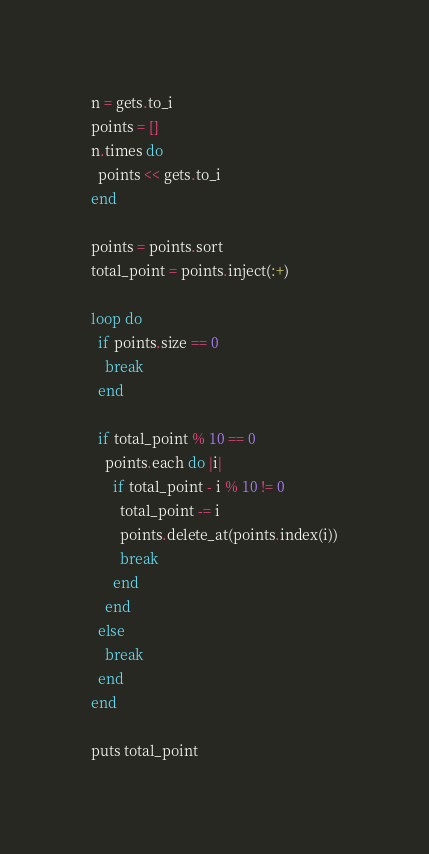<code> <loc_0><loc_0><loc_500><loc_500><_Ruby_>n = gets.to_i
points = []
n.times do
  points << gets.to_i
end

points = points.sort
total_point = points.inject(:+)

loop do
  if points.size == 0
    break
  end

  if total_point % 10 == 0
    points.each do |i|
      if total_point - i % 10 != 0
        total_point -= i
        points.delete_at(points.index(i))
        break
      end
    end
  else
    break
  end
end

puts total_point</code> 